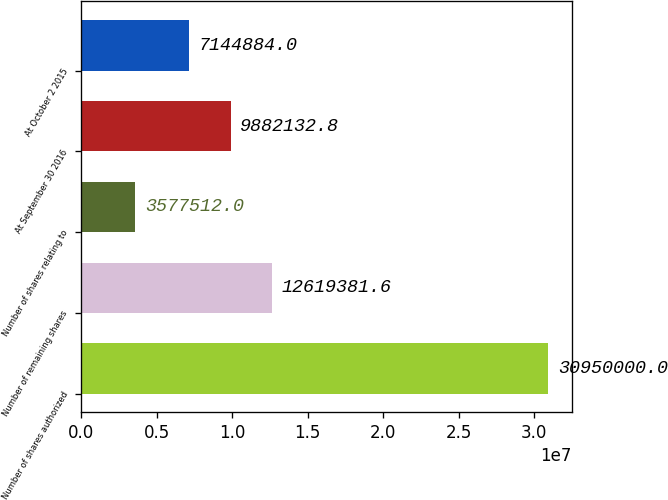Convert chart to OTSL. <chart><loc_0><loc_0><loc_500><loc_500><bar_chart><fcel>Number of shares authorized<fcel>Number of remaining shares<fcel>Number of shares relating to<fcel>At September 30 2016<fcel>At October 2 2015<nl><fcel>3.095e+07<fcel>1.26194e+07<fcel>3.57751e+06<fcel>9.88213e+06<fcel>7.14488e+06<nl></chart> 